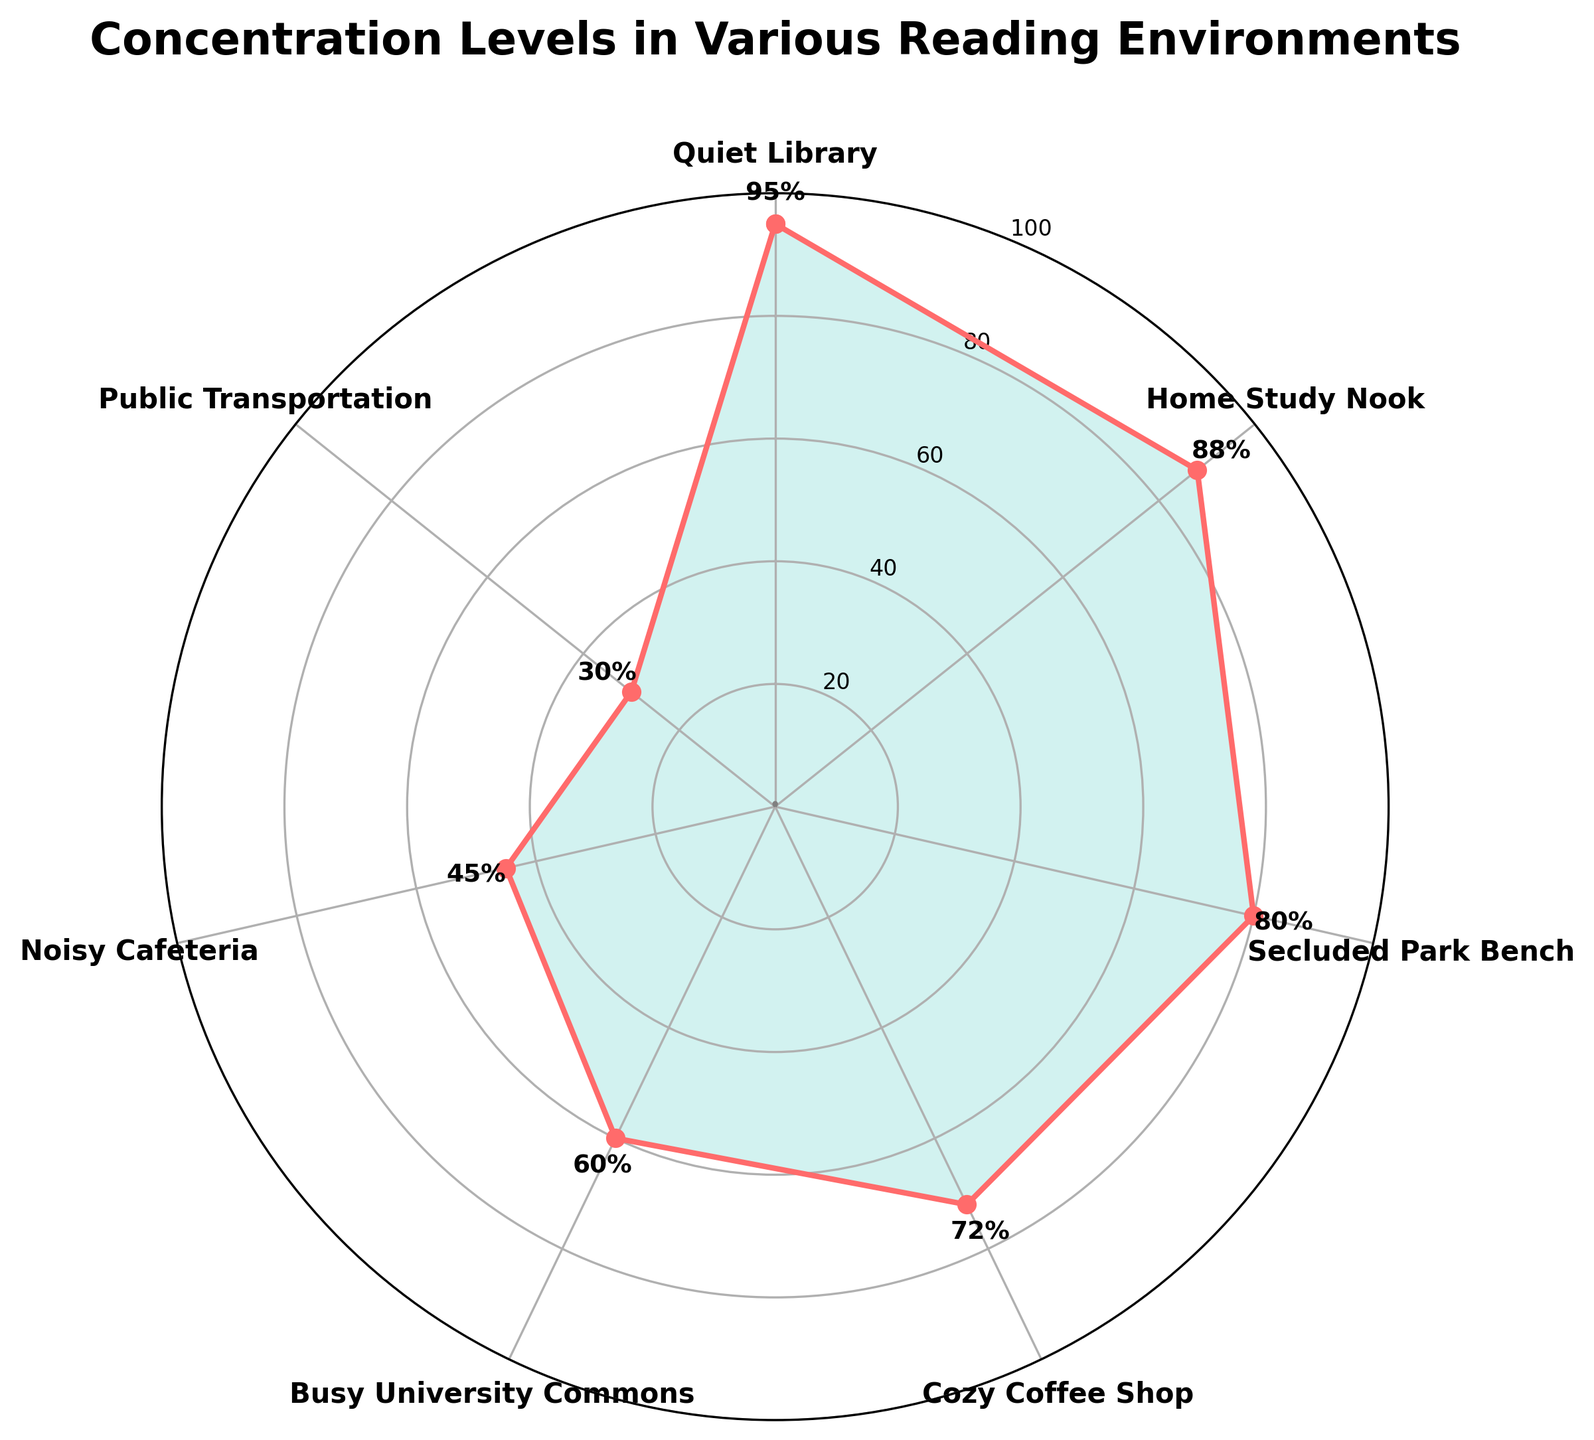What is the title of the figure? The title is usually displayed at the top of the figure, in larger font size and often bold. Here, it reads "Concentration Levels in Various Reading Environments".
Answer: Concentration Levels in Various Reading Environments Which environment shows the highest concentration level? Look at the environment labels and their corresponding concentration levels. Identify the one with the highest value; in this case, the "Quiet Library".
Answer: Quiet Library What is the concentration level in a Cozy Coffee Shop? From the figure, locate the "Cozy Coffee Shop" label and read its corresponding concentration level. It is marked next to the point in the chart with the value.
Answer: 72% How do the concentration levels compare between a Home Study Nook and a Noisy Cafeteria? Find the concentration levels for both environments: "Home Study Nook" has 88% and "Noisy Cafeteria" has 45%. Compare these two values.
Answer: Home Study Nook has higher concentration than Noisy Cafeteria What is the difference in concentration levels between a Secluded Park Bench and Busy University Commons? Locate the concentration levels for both environments: "Secluded Park Bench" (80%) and "Busy University Commons" (60%). Subtract the lower value from the higher one: 80 - 60.
Answer: 20% What range is depicted on the radial (concentration) axis? The radial axis shows the range for concentration levels. Look for the minimum and maximum values displayed on the circles; here, it ranges from 0 to 100.
Answer: 0 to 100 Which environment has the second-lowest concentration level, and what is that level? Identify the concentration levels in increasing order. The second-lowest value is next to the lowest, which is 30% in "Public Transportation". The second-lowest is 45% in "Noisy Cafeteria".
Answer: Noisy Cafeteria, 45% How many unique environments are displayed in the plot? Count all the distinct labels from the figure. Each label represents a unique environment here: "Quiet Library", "Home Study Nook", "Secluded Park Bench", "Cozy Coffee Shop", "Busy University Commons", "Noisy Cafeteria", and "Public Transportation". There are 7 environments.
Answer: 7 Which two environments have concentration levels closest to each other, and what are their levels? Compare all the concentration levels to find the smallest difference between two pairs. "Secluded Park Bench" (80%) and "Cozy Coffee Shop" (72%) have a difference of 8%, the smallest.
Answer: Secluded Park Bench (80%) and Cozy Coffee Shop (72%), difference of 8% What is the average concentration level across all environments? Add all concentration levels and divide by the number of environments. The sum is 95 + 88 + 80 + 72 + 60 + 45 + 30 = 470. Average is 470 / 7.
Answer: 67.14% 